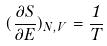Convert formula to latex. <formula><loc_0><loc_0><loc_500><loc_500>( \frac { \partial S } { \partial E } ) _ { N , V } = \frac { 1 } { T }</formula> 